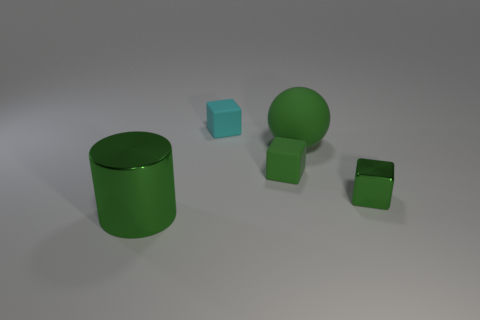What number of other shiny cylinders have the same size as the green metal cylinder?
Keep it short and to the point. 0. There is a small cyan object that is the same shape as the tiny green matte object; what is it made of?
Give a very brief answer. Rubber. What color is the metal thing that is to the right of the large metallic object?
Your answer should be compact. Green. Are there more small green matte things that are in front of the big green matte sphere than tiny purple metal cubes?
Your answer should be very brief. Yes. The cylinder is what color?
Offer a very short reply. Green. The large green thing to the right of the green cube that is behind the green shiny thing behind the large green shiny thing is what shape?
Provide a short and direct response. Sphere. There is a thing that is both behind the large metallic cylinder and on the left side of the tiny green rubber cube; what material is it?
Your answer should be compact. Rubber. There is a big thing on the right side of the cyan rubber block that is right of the cylinder; what is its shape?
Keep it short and to the point. Sphere. Are there any other things that have the same color as the large shiny cylinder?
Keep it short and to the point. Yes. Does the cyan rubber block have the same size as the green metallic thing left of the green metal cube?
Ensure brevity in your answer.  No. 